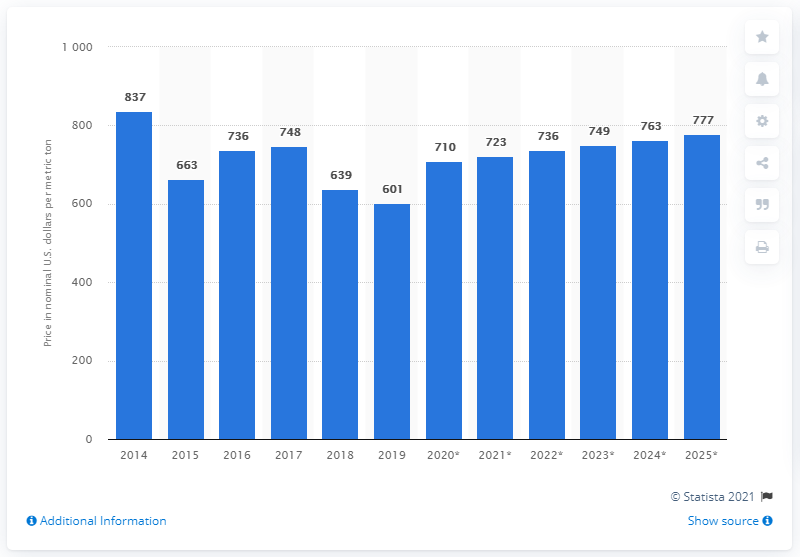Outline some significant characteristics in this image. In 2019, the average price of palm oil per metric ton was approximately 601. 